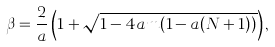Convert formula to latex. <formula><loc_0><loc_0><loc_500><loc_500>\beta = \frac { 2 } { a } \left ( 1 + \sqrt { 1 - 4 a m ( 1 - a ( N + 1 ) ) } \right ) ,</formula> 